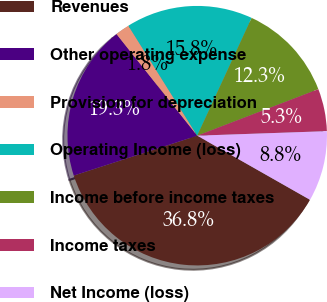Convert chart. <chart><loc_0><loc_0><loc_500><loc_500><pie_chart><fcel>Revenues<fcel>Other operating expense<fcel>Provision for depreciation<fcel>Operating Income (loss)<fcel>Income before income taxes<fcel>Income taxes<fcel>Net Income (loss)<nl><fcel>36.8%<fcel>19.29%<fcel>1.78%<fcel>15.79%<fcel>12.28%<fcel>5.28%<fcel>8.78%<nl></chart> 